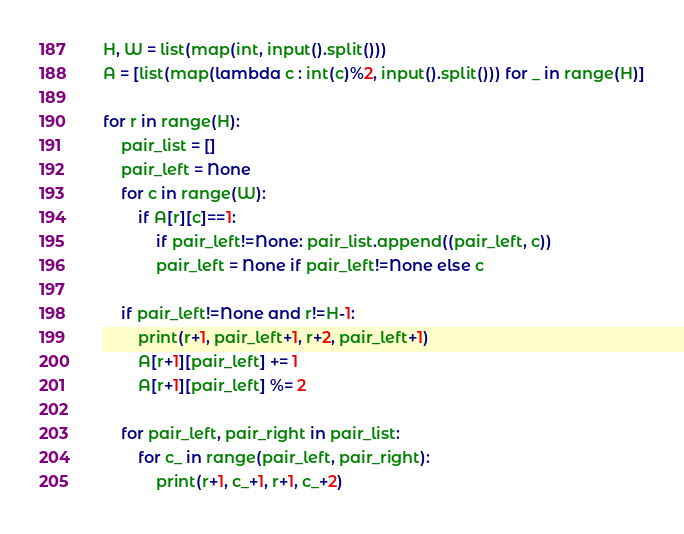<code> <loc_0><loc_0><loc_500><loc_500><_Python_>H, W = list(map(int, input().split()))
A = [list(map(lambda c : int(c)%2, input().split())) for _ in range(H)]

for r in range(H):
    pair_list = []
    pair_left = None
    for c in range(W):
        if A[r][c]==1:
            if pair_left!=None: pair_list.append((pair_left, c))
            pair_left = None if pair_left!=None else c

    if pair_left!=None and r!=H-1:
        print(r+1, pair_left+1, r+2, pair_left+1)
        A[r+1][pair_left] += 1
        A[r+1][pair_left] %= 2
      	
    for pair_left, pair_right in pair_list:
        for c_ in range(pair_left, pair_right):
            print(r+1, c_+1, r+1, c_+2)</code> 